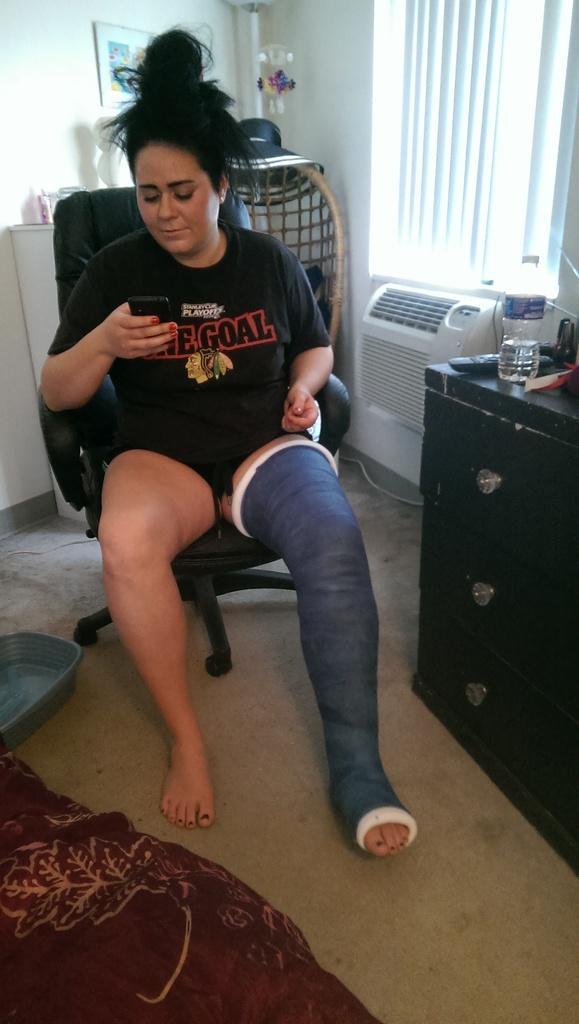Describe this image in one or two sentences. In this picture there is a lady sitting on the chair and their is a band on her left leg. 